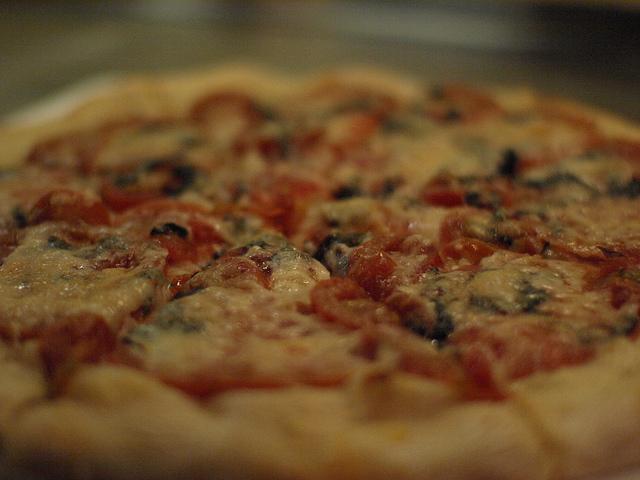How many slices have been picked?
Answer briefly. 0. What is on the pizza?
Answer briefly. Cheese. What food is this?
Answer briefly. Pizza. Is this a normal shape for a pizza?
Give a very brief answer. Yes. Is the pizza sliced?
Write a very short answer. Yes. What shape is this food?
Answer briefly. Circle. Is the pizza burnt?
Be succinct. No. Has the pizza been sliced?
Concise answer only. Yes. 